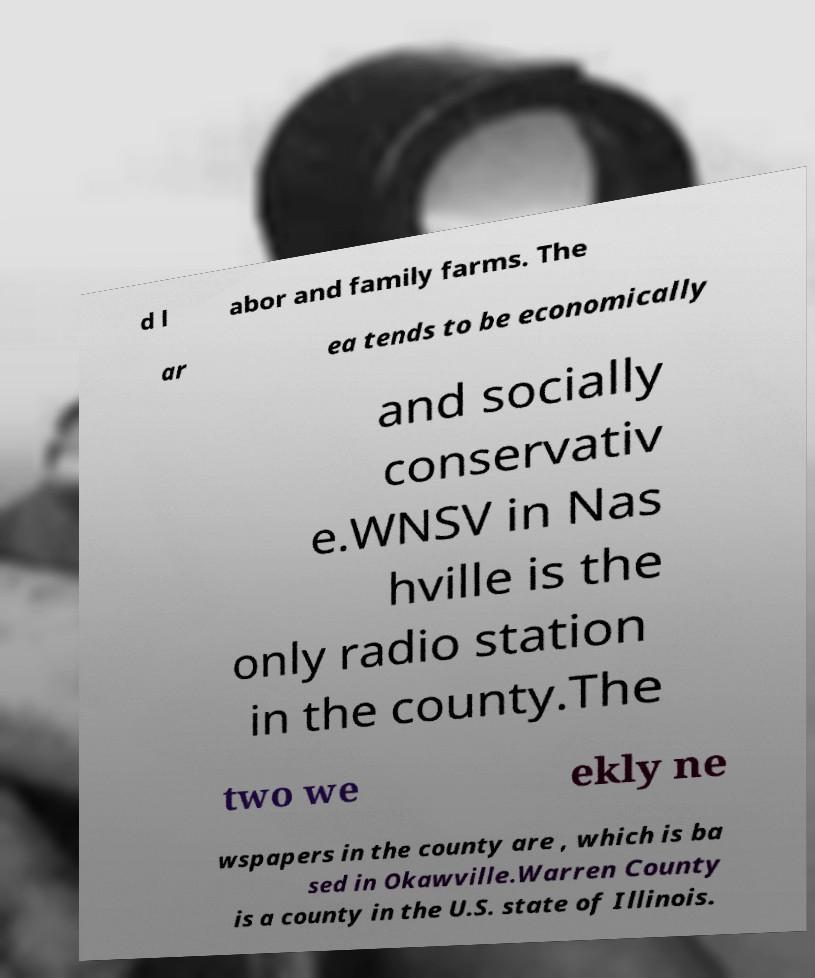For documentation purposes, I need the text within this image transcribed. Could you provide that? d l abor and family farms. The ar ea tends to be economically and socially conservativ e.WNSV in Nas hville is the only radio station in the county.The two we ekly ne wspapers in the county are , which is ba sed in Okawville.Warren County is a county in the U.S. state of Illinois. 